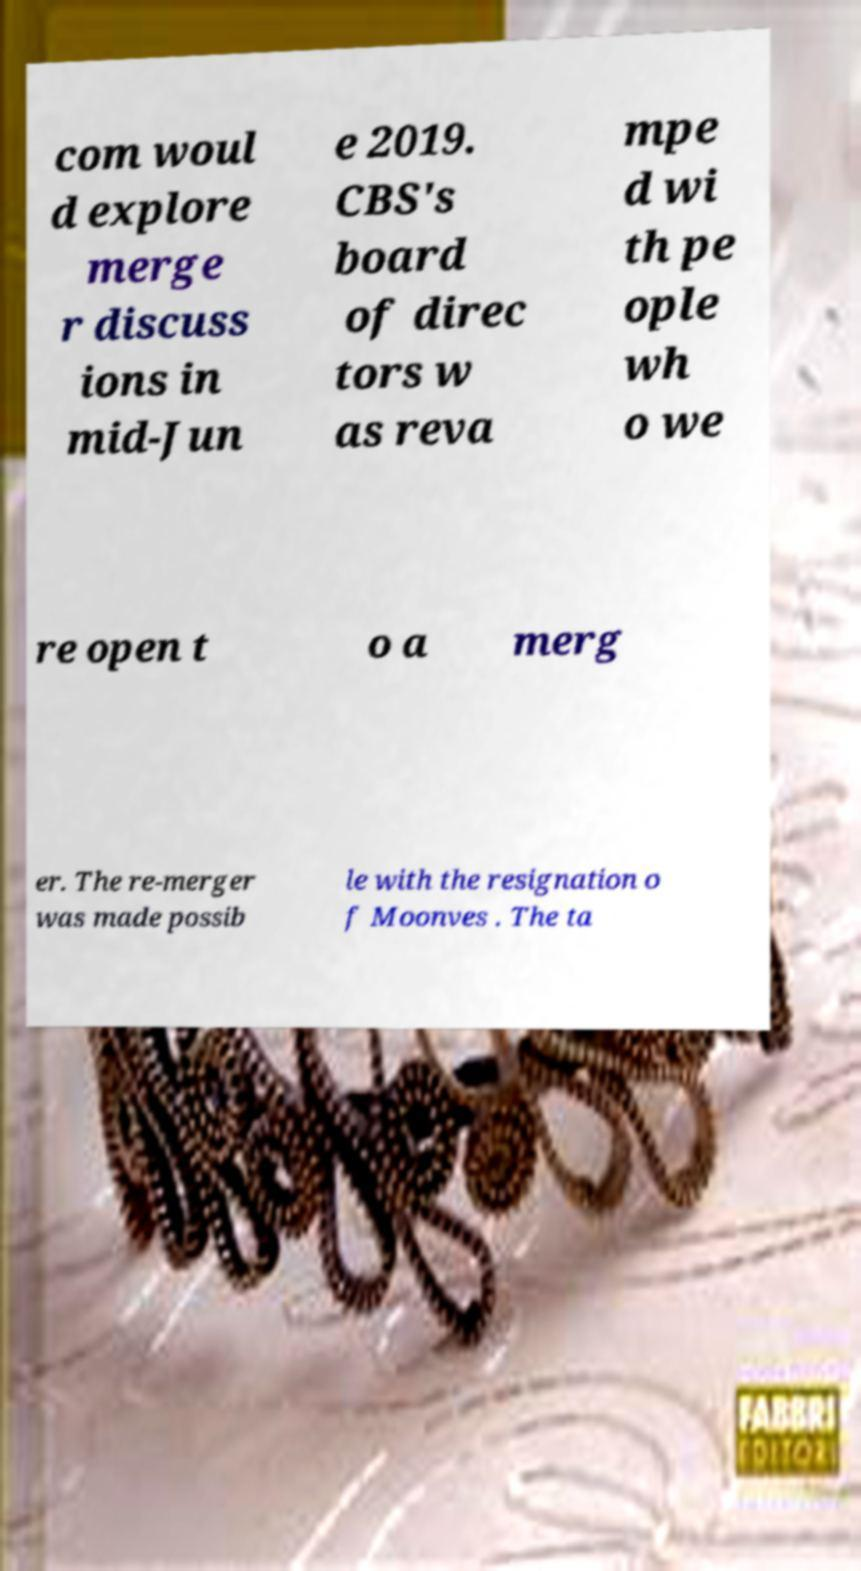Can you read and provide the text displayed in the image?This photo seems to have some interesting text. Can you extract and type it out for me? com woul d explore merge r discuss ions in mid-Jun e 2019. CBS's board of direc tors w as reva mpe d wi th pe ople wh o we re open t o a merg er. The re-merger was made possib le with the resignation o f Moonves . The ta 